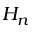Convert formula to latex. <formula><loc_0><loc_0><loc_500><loc_500>H _ { n }</formula> 